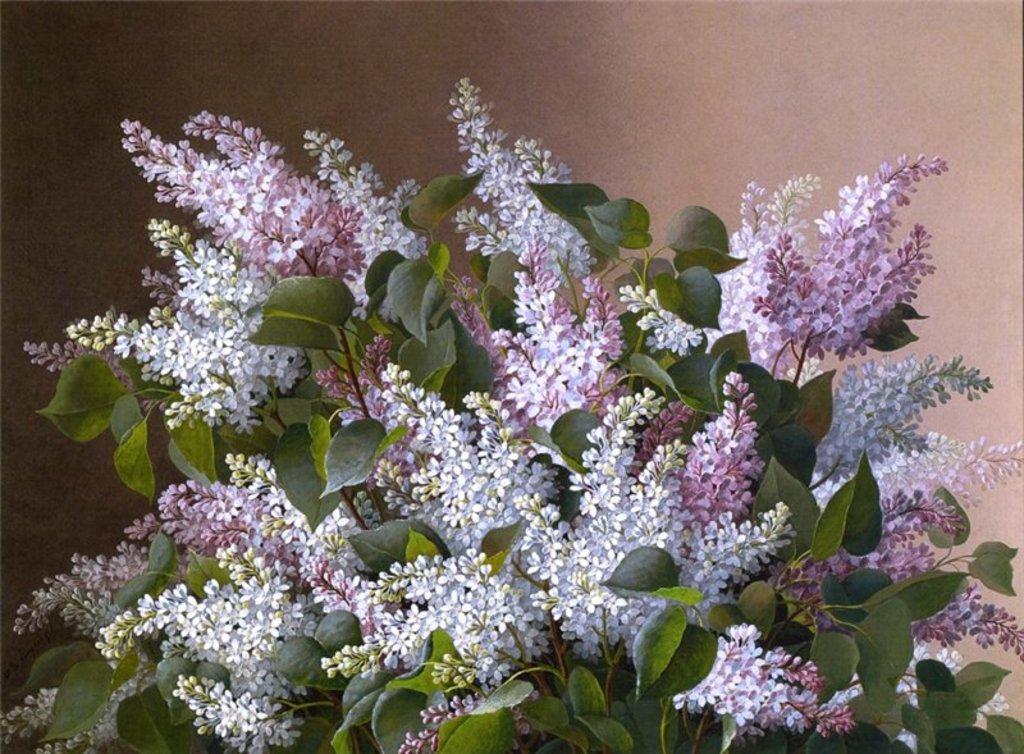How would you summarize this image in a sentence or two? In the center of the image we can see the flowers and leaves. In the background of the image we can see the wall. 